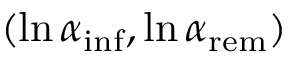<formula> <loc_0><loc_0><loc_500><loc_500>( \ln { \alpha _ { i n f } } , \ln { \alpha _ { r e m } } )</formula> 